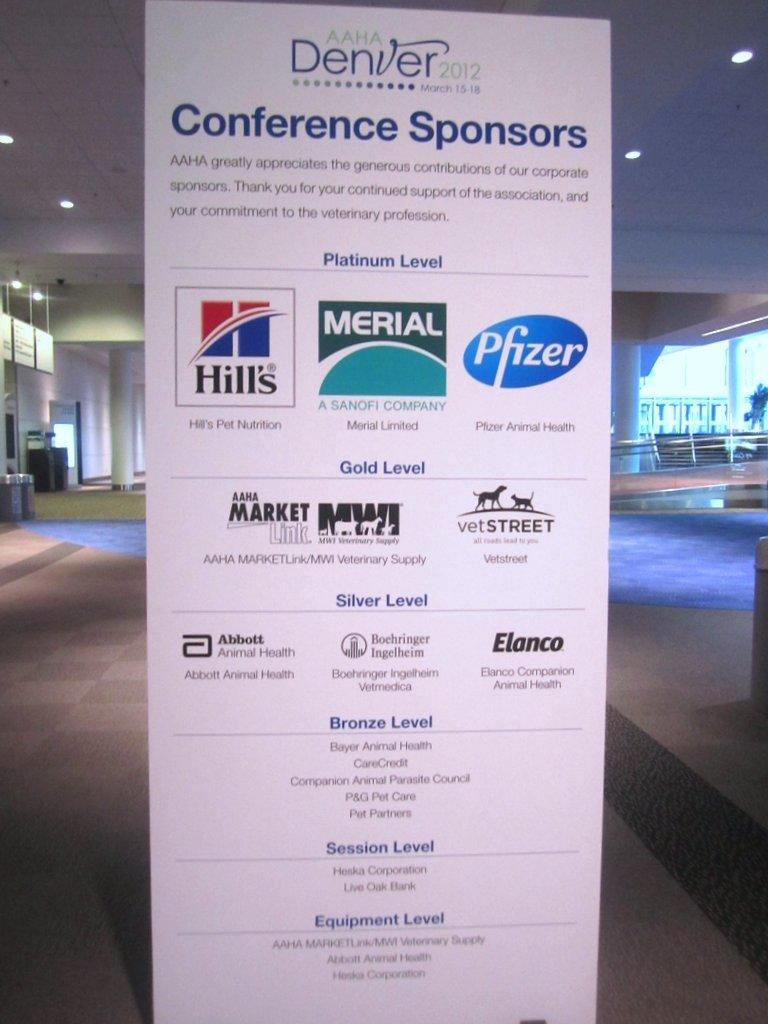<image>
Relay a brief, clear account of the picture shown. Poster that list sponsors on it for AAHA Denver 2012. 